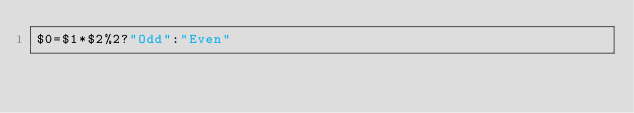<code> <loc_0><loc_0><loc_500><loc_500><_Awk_>$0=$1*$2%2?"Odd":"Even"</code> 